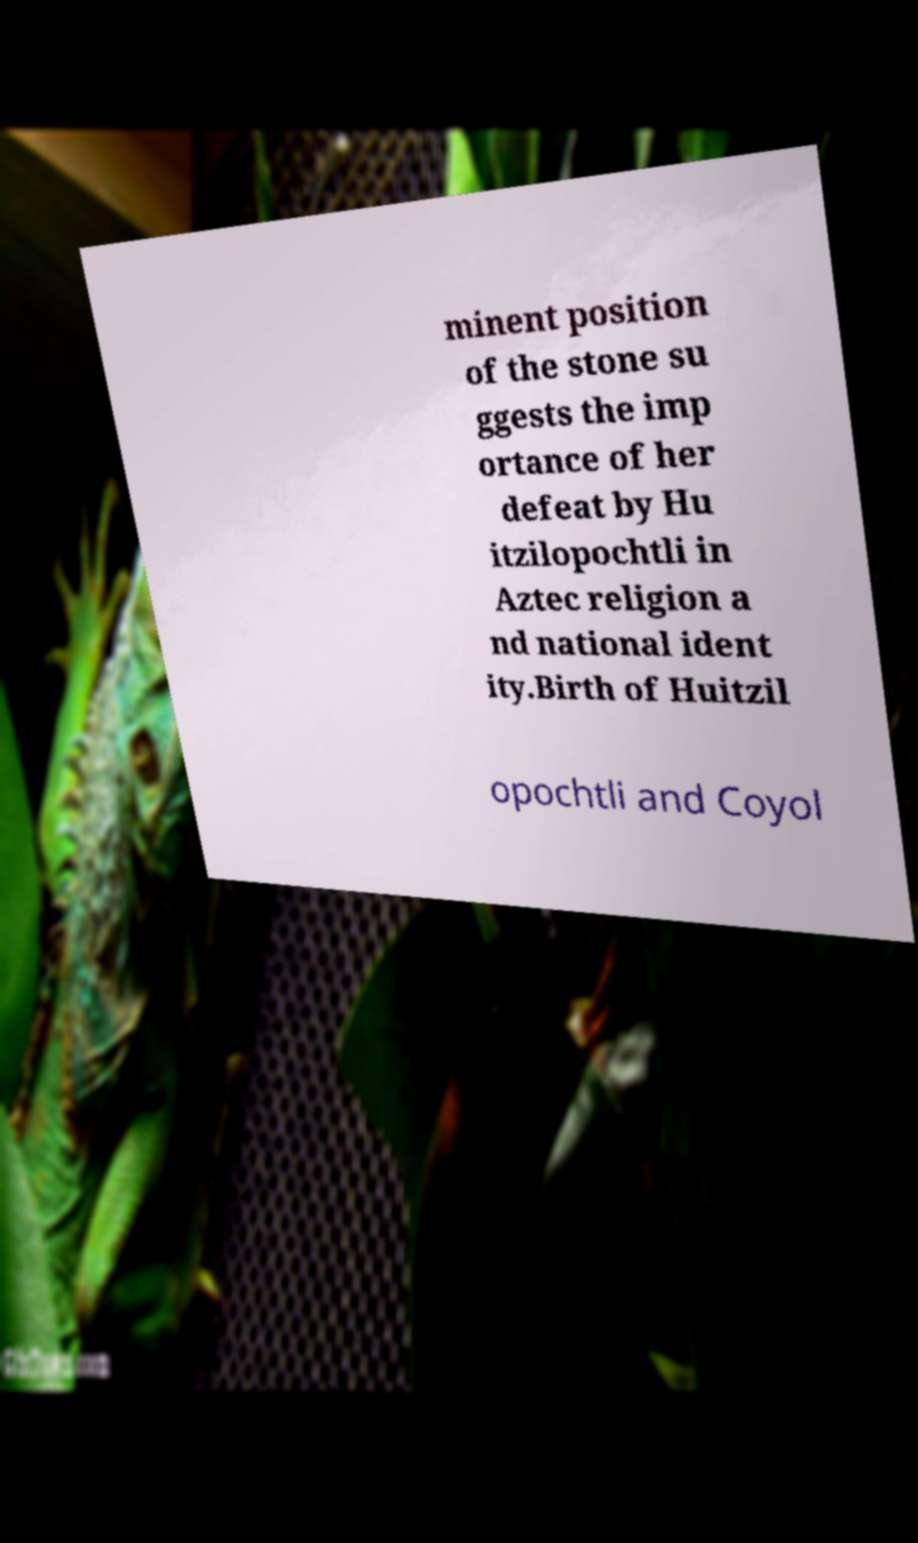Can you accurately transcribe the text from the provided image for me? minent position of the stone su ggests the imp ortance of her defeat by Hu itzilopochtli in Aztec religion a nd national ident ity.Birth of Huitzil opochtli and Coyol 